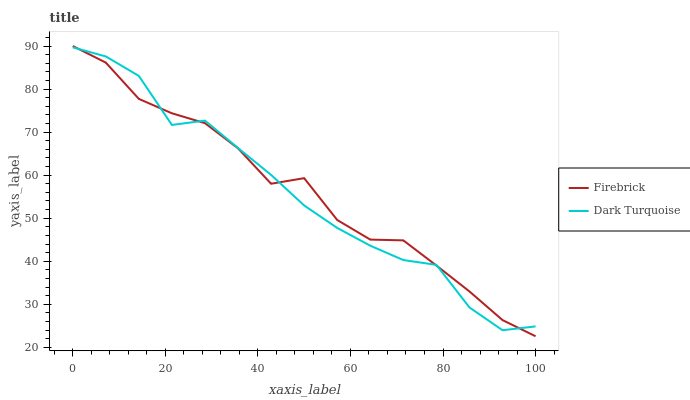Does Dark Turquoise have the minimum area under the curve?
Answer yes or no. Yes. Does Firebrick have the maximum area under the curve?
Answer yes or no. Yes. Does Firebrick have the minimum area under the curve?
Answer yes or no. No. Is Dark Turquoise the smoothest?
Answer yes or no. Yes. Is Firebrick the roughest?
Answer yes or no. Yes. Is Firebrick the smoothest?
Answer yes or no. No. Does Firebrick have the lowest value?
Answer yes or no. Yes. Does Firebrick have the highest value?
Answer yes or no. Yes. Does Dark Turquoise intersect Firebrick?
Answer yes or no. Yes. Is Dark Turquoise less than Firebrick?
Answer yes or no. No. Is Dark Turquoise greater than Firebrick?
Answer yes or no. No. 